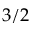<formula> <loc_0><loc_0><loc_500><loc_500>3 / 2</formula> 